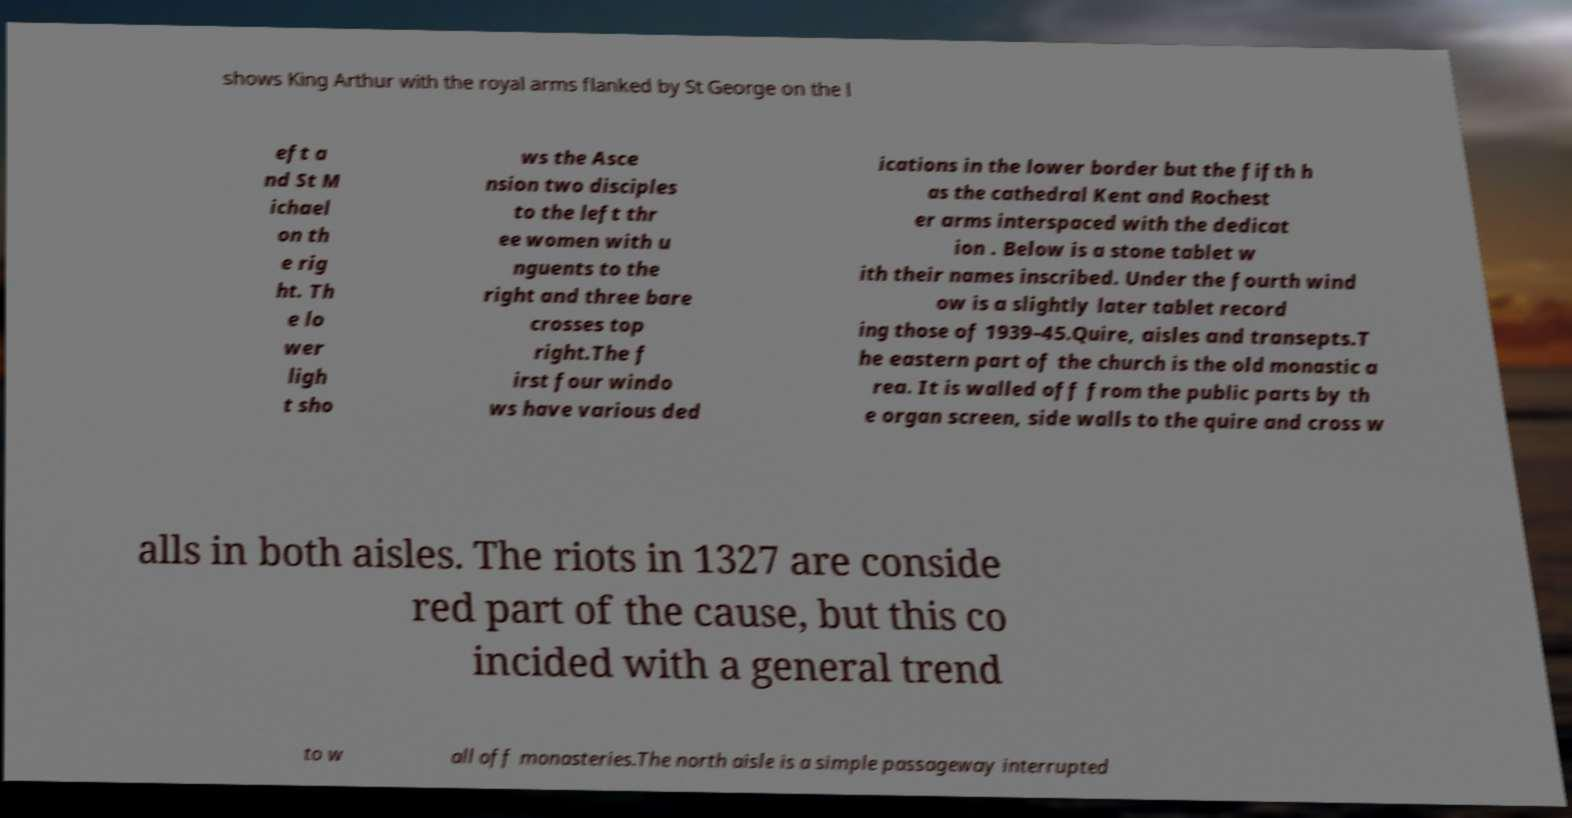What messages or text are displayed in this image? I need them in a readable, typed format. shows King Arthur with the royal arms flanked by St George on the l eft a nd St M ichael on th e rig ht. Th e lo wer ligh t sho ws the Asce nsion two disciples to the left thr ee women with u nguents to the right and three bare crosses top right.The f irst four windo ws have various ded ications in the lower border but the fifth h as the cathedral Kent and Rochest er arms interspaced with the dedicat ion . Below is a stone tablet w ith their names inscribed. Under the fourth wind ow is a slightly later tablet record ing those of 1939–45.Quire, aisles and transepts.T he eastern part of the church is the old monastic a rea. It is walled off from the public parts by th e organ screen, side walls to the quire and cross w alls in both aisles. The riots in 1327 are conside red part of the cause, but this co incided with a general trend to w all off monasteries.The north aisle is a simple passageway interrupted 